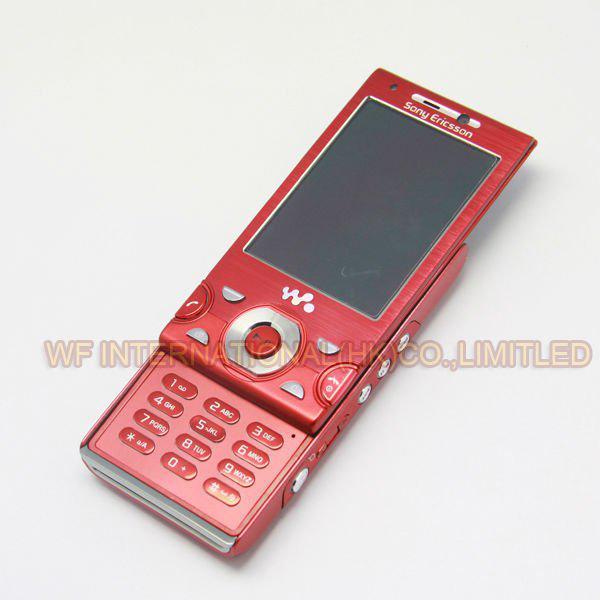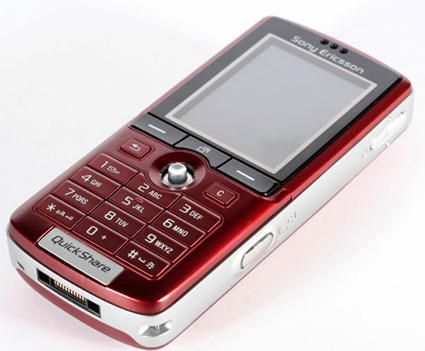The first image is the image on the left, the second image is the image on the right. Analyze the images presented: Is the assertion "There are exactly two phones." valid? Answer yes or no. Yes. The first image is the image on the left, the second image is the image on the right. Given the left and right images, does the statement "There are only two phones." hold true? Answer yes or no. Yes. 